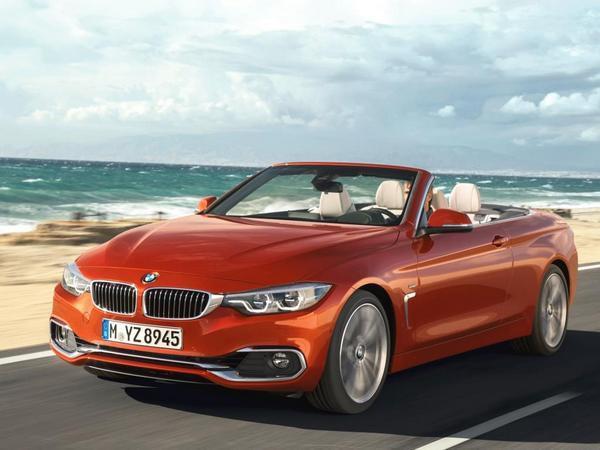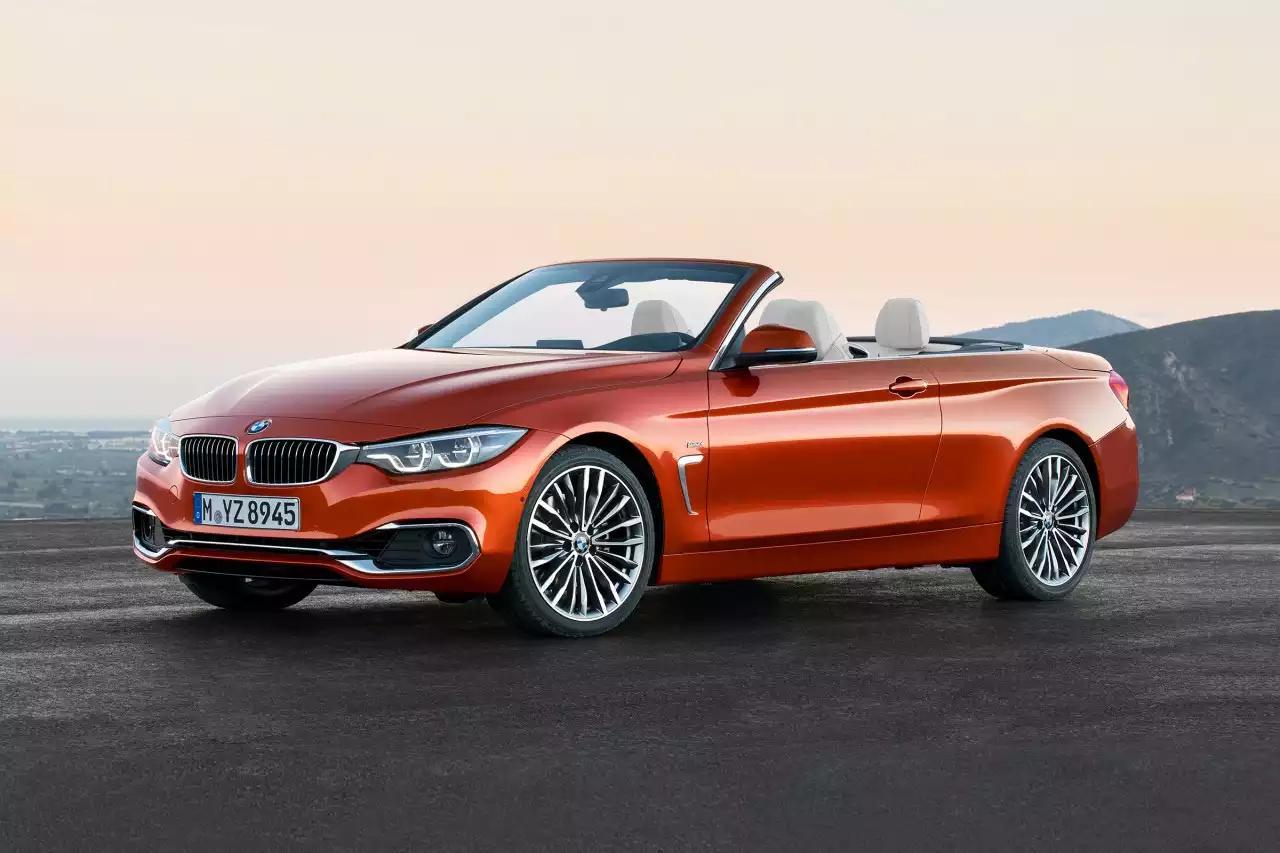The first image is the image on the left, the second image is the image on the right. Examine the images to the left and right. Is the description "One image features a red convertible and a blue car with a top, and the vehicles face opposite directions." accurate? Answer yes or no. No. The first image is the image on the left, the second image is the image on the right. Considering the images on both sides, is "The left hand image shows one red and one blue car, while the right hand image shows exactly one red convertible vehicle." valid? Answer yes or no. No. 